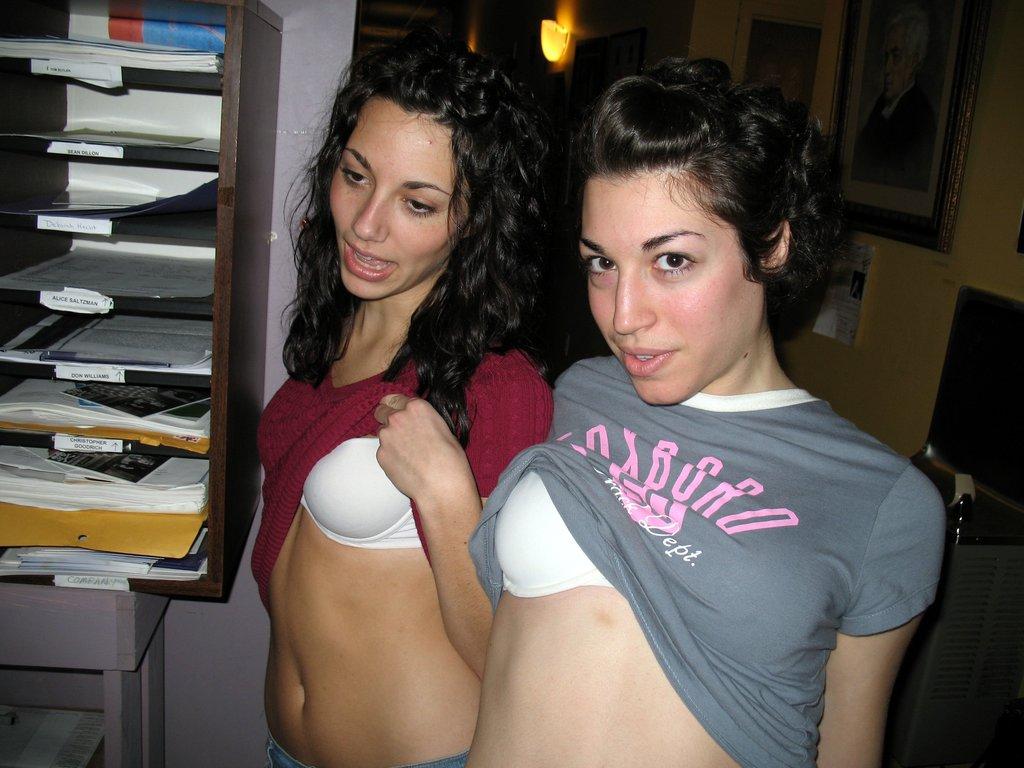What is the last letter on the grey shirt?
Provide a succinct answer. O. 